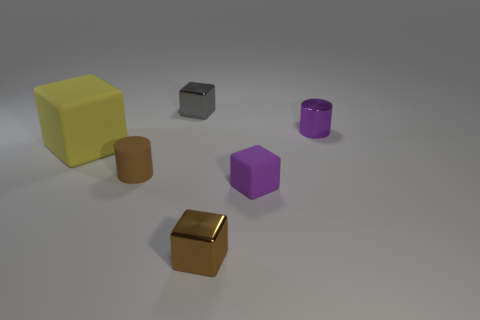What is the size of the matte thing that is the same color as the metal cylinder?
Offer a terse response. Small. There is a shiny thing that is the same color as the small rubber cube; what shape is it?
Keep it short and to the point. Cylinder. How many things are either big yellow metallic cubes or tiny purple matte objects?
Your answer should be very brief. 1. Is the shape of the brown object that is in front of the brown matte thing the same as the tiny purple thing behind the large object?
Provide a short and direct response. No. There is a small purple thing that is behind the brown cylinder; what shape is it?
Offer a very short reply. Cylinder. Are there an equal number of yellow matte blocks in front of the small rubber cylinder and purple cubes to the right of the tiny purple cube?
Keep it short and to the point. Yes. What number of things are large purple metal cylinders or small blocks that are in front of the gray metal cube?
Offer a very short reply. 2. There is a tiny object that is both to the right of the brown block and in front of the metal cylinder; what is its shape?
Provide a short and direct response. Cube. There is a small cylinder that is in front of the cylinder on the right side of the gray thing; what is its material?
Offer a terse response. Rubber. Do the small cylinder that is behind the large rubber object and the tiny purple block have the same material?
Ensure brevity in your answer.  No. 